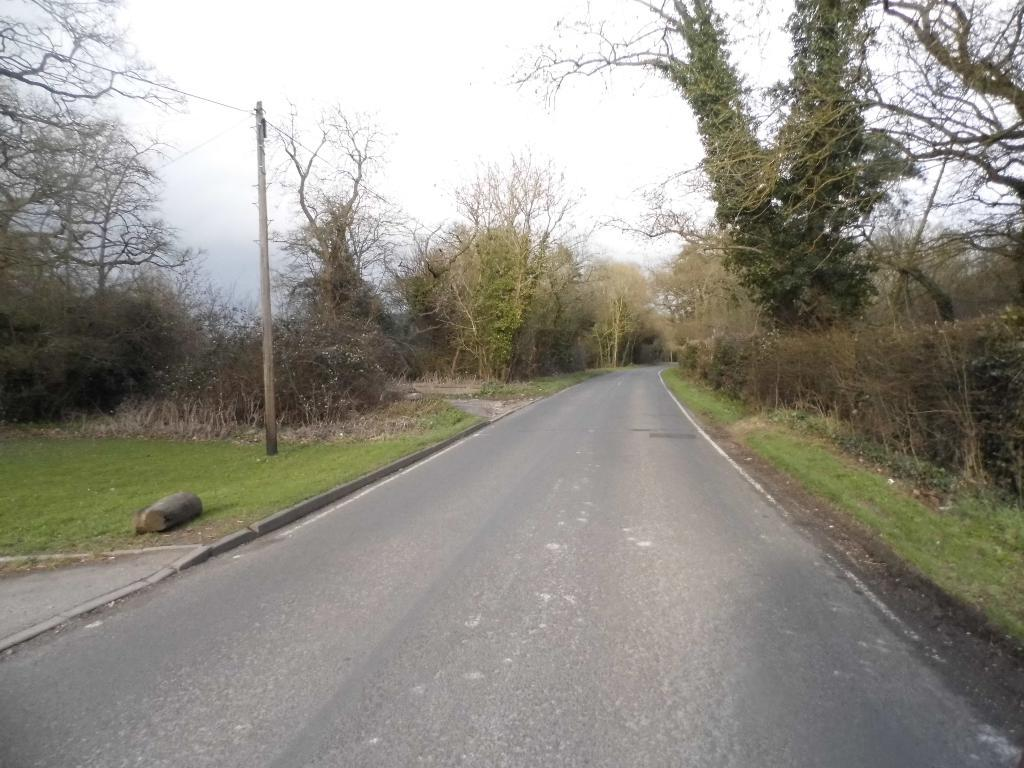What type of vegetation is present in the image? There are trees in the image. What is the color of the trees in the image? The trees are green in color. What other structures can be seen in the image besides the trees? There are electric poles in the image. What is the color of the sky in the image? The sky is white in color. What type of vessel is being used to reduce friction between the trees in the image? There is no vessel or friction mentioned in the image; it only features trees, electric poles, and a white sky. 